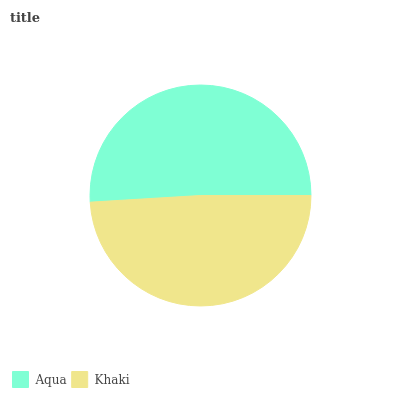Is Khaki the minimum?
Answer yes or no. Yes. Is Aqua the maximum?
Answer yes or no. Yes. Is Khaki the maximum?
Answer yes or no. No. Is Aqua greater than Khaki?
Answer yes or no. Yes. Is Khaki less than Aqua?
Answer yes or no. Yes. Is Khaki greater than Aqua?
Answer yes or no. No. Is Aqua less than Khaki?
Answer yes or no. No. Is Aqua the high median?
Answer yes or no. Yes. Is Khaki the low median?
Answer yes or no. Yes. Is Khaki the high median?
Answer yes or no. No. Is Aqua the low median?
Answer yes or no. No. 